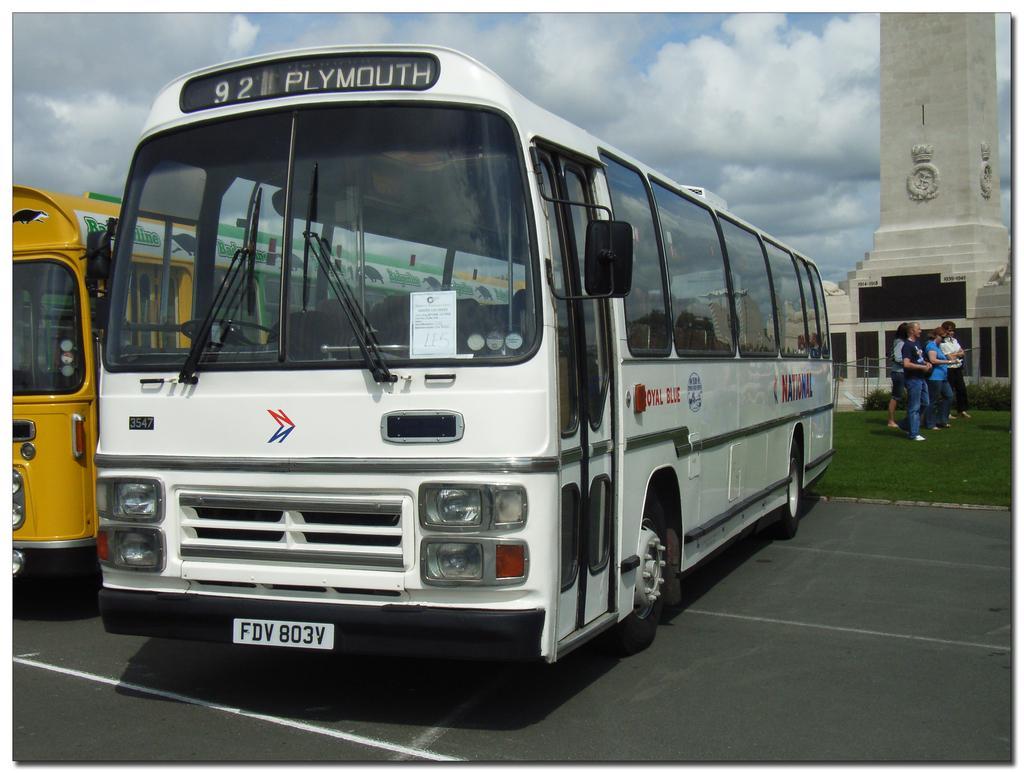Describe this image in one or two sentences. In this picture I can see vehicles on the road. I can see people on the green grass. I can see the tower on the right side. I can see clouds in the sky. 